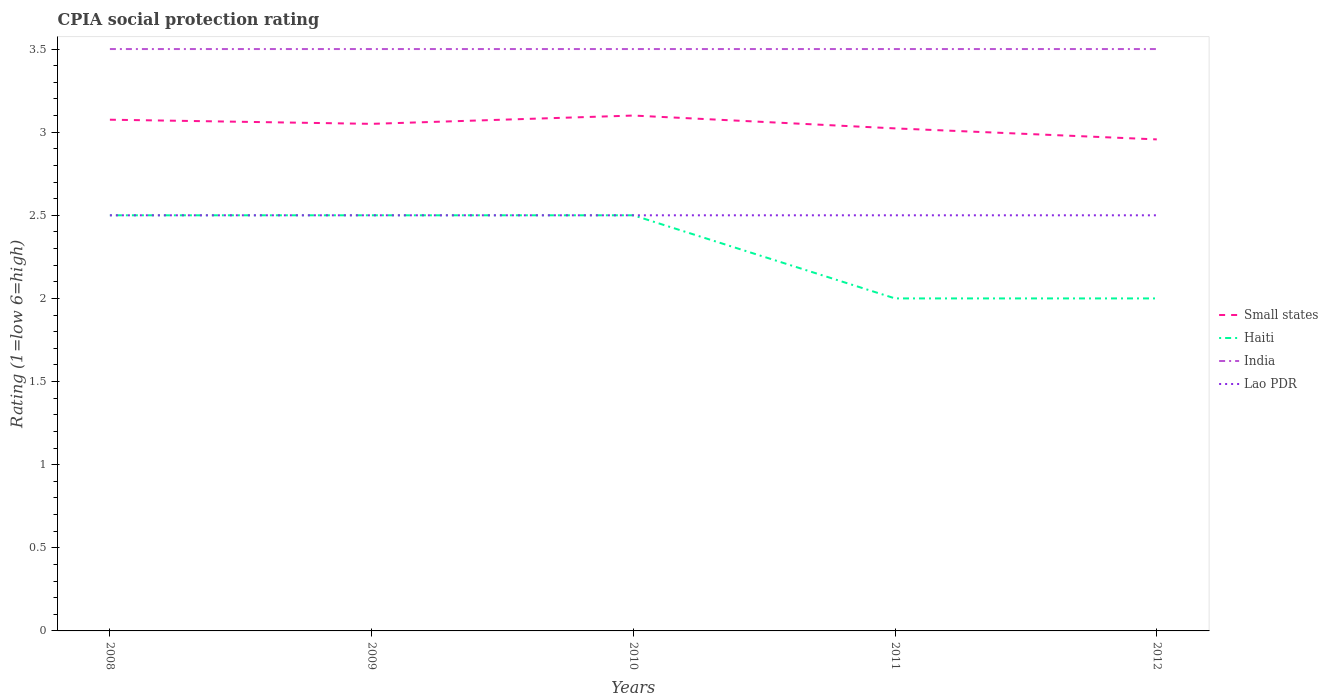Across all years, what is the maximum CPIA rating in Lao PDR?
Make the answer very short. 2.5. In which year was the CPIA rating in Haiti maximum?
Provide a short and direct response. 2011. What is the difference between the highest and the second highest CPIA rating in Haiti?
Provide a succinct answer. 0.5. Is the CPIA rating in Haiti strictly greater than the CPIA rating in India over the years?
Make the answer very short. Yes. How many lines are there?
Make the answer very short. 4. Are the values on the major ticks of Y-axis written in scientific E-notation?
Your response must be concise. No. What is the title of the graph?
Offer a very short reply. CPIA social protection rating. What is the label or title of the X-axis?
Keep it short and to the point. Years. What is the Rating (1=low 6=high) of Small states in 2008?
Offer a very short reply. 3.08. What is the Rating (1=low 6=high) in Haiti in 2008?
Your answer should be very brief. 2.5. What is the Rating (1=low 6=high) in India in 2008?
Ensure brevity in your answer.  3.5. What is the Rating (1=low 6=high) in Small states in 2009?
Give a very brief answer. 3.05. What is the Rating (1=low 6=high) of Haiti in 2010?
Your response must be concise. 2.5. What is the Rating (1=low 6=high) in Lao PDR in 2010?
Offer a very short reply. 2.5. What is the Rating (1=low 6=high) of Small states in 2011?
Keep it short and to the point. 3.02. What is the Rating (1=low 6=high) of Small states in 2012?
Keep it short and to the point. 2.96. Across all years, what is the maximum Rating (1=low 6=high) of Small states?
Make the answer very short. 3.1. Across all years, what is the maximum Rating (1=low 6=high) in Lao PDR?
Your response must be concise. 2.5. Across all years, what is the minimum Rating (1=low 6=high) of Small states?
Provide a short and direct response. 2.96. Across all years, what is the minimum Rating (1=low 6=high) in Haiti?
Your answer should be very brief. 2. What is the total Rating (1=low 6=high) of Small states in the graph?
Ensure brevity in your answer.  15.2. What is the difference between the Rating (1=low 6=high) in Small states in 2008 and that in 2009?
Make the answer very short. 0.03. What is the difference between the Rating (1=low 6=high) of Lao PDR in 2008 and that in 2009?
Make the answer very short. 0. What is the difference between the Rating (1=low 6=high) in Small states in 2008 and that in 2010?
Keep it short and to the point. -0.03. What is the difference between the Rating (1=low 6=high) in India in 2008 and that in 2010?
Keep it short and to the point. 0. What is the difference between the Rating (1=low 6=high) of Small states in 2008 and that in 2011?
Provide a short and direct response. 0.05. What is the difference between the Rating (1=low 6=high) of Haiti in 2008 and that in 2011?
Your answer should be compact. 0.5. What is the difference between the Rating (1=low 6=high) in India in 2008 and that in 2011?
Provide a succinct answer. 0. What is the difference between the Rating (1=low 6=high) in Small states in 2008 and that in 2012?
Ensure brevity in your answer.  0.12. What is the difference between the Rating (1=low 6=high) in Haiti in 2008 and that in 2012?
Your answer should be compact. 0.5. What is the difference between the Rating (1=low 6=high) in Lao PDR in 2009 and that in 2010?
Make the answer very short. 0. What is the difference between the Rating (1=low 6=high) in Small states in 2009 and that in 2011?
Offer a terse response. 0.03. What is the difference between the Rating (1=low 6=high) in India in 2009 and that in 2011?
Provide a short and direct response. 0. What is the difference between the Rating (1=low 6=high) of Lao PDR in 2009 and that in 2011?
Your answer should be compact. 0. What is the difference between the Rating (1=low 6=high) of Small states in 2009 and that in 2012?
Your answer should be very brief. 0.09. What is the difference between the Rating (1=low 6=high) in Lao PDR in 2009 and that in 2012?
Keep it short and to the point. 0. What is the difference between the Rating (1=low 6=high) of Small states in 2010 and that in 2011?
Offer a very short reply. 0.08. What is the difference between the Rating (1=low 6=high) in Haiti in 2010 and that in 2011?
Your answer should be very brief. 0.5. What is the difference between the Rating (1=low 6=high) of Lao PDR in 2010 and that in 2011?
Provide a succinct answer. 0. What is the difference between the Rating (1=low 6=high) of Small states in 2010 and that in 2012?
Your answer should be compact. 0.14. What is the difference between the Rating (1=low 6=high) in Haiti in 2010 and that in 2012?
Provide a short and direct response. 0.5. What is the difference between the Rating (1=low 6=high) of Lao PDR in 2010 and that in 2012?
Provide a short and direct response. 0. What is the difference between the Rating (1=low 6=high) in Small states in 2011 and that in 2012?
Give a very brief answer. 0.07. What is the difference between the Rating (1=low 6=high) in Haiti in 2011 and that in 2012?
Offer a terse response. 0. What is the difference between the Rating (1=low 6=high) of Lao PDR in 2011 and that in 2012?
Offer a very short reply. 0. What is the difference between the Rating (1=low 6=high) in Small states in 2008 and the Rating (1=low 6=high) in Haiti in 2009?
Make the answer very short. 0.57. What is the difference between the Rating (1=low 6=high) in Small states in 2008 and the Rating (1=low 6=high) in India in 2009?
Make the answer very short. -0.42. What is the difference between the Rating (1=low 6=high) in Small states in 2008 and the Rating (1=low 6=high) in Lao PDR in 2009?
Keep it short and to the point. 0.57. What is the difference between the Rating (1=low 6=high) in Haiti in 2008 and the Rating (1=low 6=high) in India in 2009?
Ensure brevity in your answer.  -1. What is the difference between the Rating (1=low 6=high) of Haiti in 2008 and the Rating (1=low 6=high) of Lao PDR in 2009?
Your answer should be compact. 0. What is the difference between the Rating (1=low 6=high) in Small states in 2008 and the Rating (1=low 6=high) in Haiti in 2010?
Make the answer very short. 0.57. What is the difference between the Rating (1=low 6=high) of Small states in 2008 and the Rating (1=low 6=high) of India in 2010?
Offer a terse response. -0.42. What is the difference between the Rating (1=low 6=high) in Small states in 2008 and the Rating (1=low 6=high) in Lao PDR in 2010?
Make the answer very short. 0.57. What is the difference between the Rating (1=low 6=high) in India in 2008 and the Rating (1=low 6=high) in Lao PDR in 2010?
Offer a very short reply. 1. What is the difference between the Rating (1=low 6=high) of Small states in 2008 and the Rating (1=low 6=high) of Haiti in 2011?
Provide a short and direct response. 1.07. What is the difference between the Rating (1=low 6=high) of Small states in 2008 and the Rating (1=low 6=high) of India in 2011?
Your answer should be compact. -0.42. What is the difference between the Rating (1=low 6=high) in Small states in 2008 and the Rating (1=low 6=high) in Lao PDR in 2011?
Offer a terse response. 0.57. What is the difference between the Rating (1=low 6=high) in Haiti in 2008 and the Rating (1=low 6=high) in India in 2011?
Provide a succinct answer. -1. What is the difference between the Rating (1=low 6=high) of Small states in 2008 and the Rating (1=low 6=high) of Haiti in 2012?
Offer a very short reply. 1.07. What is the difference between the Rating (1=low 6=high) of Small states in 2008 and the Rating (1=low 6=high) of India in 2012?
Your answer should be very brief. -0.42. What is the difference between the Rating (1=low 6=high) in Small states in 2008 and the Rating (1=low 6=high) in Lao PDR in 2012?
Offer a terse response. 0.57. What is the difference between the Rating (1=low 6=high) in Haiti in 2008 and the Rating (1=low 6=high) in Lao PDR in 2012?
Give a very brief answer. 0. What is the difference between the Rating (1=low 6=high) in India in 2008 and the Rating (1=low 6=high) in Lao PDR in 2012?
Offer a terse response. 1. What is the difference between the Rating (1=low 6=high) of Small states in 2009 and the Rating (1=low 6=high) of Haiti in 2010?
Your answer should be compact. 0.55. What is the difference between the Rating (1=low 6=high) of Small states in 2009 and the Rating (1=low 6=high) of India in 2010?
Offer a terse response. -0.45. What is the difference between the Rating (1=low 6=high) in Small states in 2009 and the Rating (1=low 6=high) in Lao PDR in 2010?
Offer a very short reply. 0.55. What is the difference between the Rating (1=low 6=high) in Haiti in 2009 and the Rating (1=low 6=high) in Lao PDR in 2010?
Offer a terse response. 0. What is the difference between the Rating (1=low 6=high) of Small states in 2009 and the Rating (1=low 6=high) of Haiti in 2011?
Give a very brief answer. 1.05. What is the difference between the Rating (1=low 6=high) in Small states in 2009 and the Rating (1=low 6=high) in India in 2011?
Give a very brief answer. -0.45. What is the difference between the Rating (1=low 6=high) of Small states in 2009 and the Rating (1=low 6=high) of Lao PDR in 2011?
Give a very brief answer. 0.55. What is the difference between the Rating (1=low 6=high) in Haiti in 2009 and the Rating (1=low 6=high) in Lao PDR in 2011?
Provide a succinct answer. 0. What is the difference between the Rating (1=low 6=high) in Small states in 2009 and the Rating (1=low 6=high) in India in 2012?
Ensure brevity in your answer.  -0.45. What is the difference between the Rating (1=low 6=high) of Small states in 2009 and the Rating (1=low 6=high) of Lao PDR in 2012?
Provide a short and direct response. 0.55. What is the difference between the Rating (1=low 6=high) in Small states in 2010 and the Rating (1=low 6=high) in Lao PDR in 2011?
Provide a short and direct response. 0.6. What is the difference between the Rating (1=low 6=high) of Small states in 2010 and the Rating (1=low 6=high) of Haiti in 2012?
Give a very brief answer. 1.1. What is the difference between the Rating (1=low 6=high) in Small states in 2010 and the Rating (1=low 6=high) in Lao PDR in 2012?
Give a very brief answer. 0.6. What is the difference between the Rating (1=low 6=high) in Haiti in 2010 and the Rating (1=low 6=high) in Lao PDR in 2012?
Offer a very short reply. 0. What is the difference between the Rating (1=low 6=high) in India in 2010 and the Rating (1=low 6=high) in Lao PDR in 2012?
Offer a very short reply. 1. What is the difference between the Rating (1=low 6=high) of Small states in 2011 and the Rating (1=low 6=high) of Haiti in 2012?
Give a very brief answer. 1.02. What is the difference between the Rating (1=low 6=high) in Small states in 2011 and the Rating (1=low 6=high) in India in 2012?
Offer a very short reply. -0.48. What is the difference between the Rating (1=low 6=high) in Small states in 2011 and the Rating (1=low 6=high) in Lao PDR in 2012?
Provide a short and direct response. 0.52. What is the difference between the Rating (1=low 6=high) in Haiti in 2011 and the Rating (1=low 6=high) in Lao PDR in 2012?
Provide a succinct answer. -0.5. What is the difference between the Rating (1=low 6=high) in India in 2011 and the Rating (1=low 6=high) in Lao PDR in 2012?
Make the answer very short. 1. What is the average Rating (1=low 6=high) in Small states per year?
Your answer should be very brief. 3.04. What is the average Rating (1=low 6=high) of Lao PDR per year?
Offer a very short reply. 2.5. In the year 2008, what is the difference between the Rating (1=low 6=high) of Small states and Rating (1=low 6=high) of Haiti?
Give a very brief answer. 0.57. In the year 2008, what is the difference between the Rating (1=low 6=high) of Small states and Rating (1=low 6=high) of India?
Ensure brevity in your answer.  -0.42. In the year 2008, what is the difference between the Rating (1=low 6=high) of Small states and Rating (1=low 6=high) of Lao PDR?
Provide a succinct answer. 0.57. In the year 2008, what is the difference between the Rating (1=low 6=high) of Haiti and Rating (1=low 6=high) of India?
Offer a terse response. -1. In the year 2008, what is the difference between the Rating (1=low 6=high) in Haiti and Rating (1=low 6=high) in Lao PDR?
Offer a very short reply. 0. In the year 2008, what is the difference between the Rating (1=low 6=high) in India and Rating (1=low 6=high) in Lao PDR?
Offer a terse response. 1. In the year 2009, what is the difference between the Rating (1=low 6=high) of Small states and Rating (1=low 6=high) of Haiti?
Your answer should be compact. 0.55. In the year 2009, what is the difference between the Rating (1=low 6=high) in Small states and Rating (1=low 6=high) in India?
Keep it short and to the point. -0.45. In the year 2009, what is the difference between the Rating (1=low 6=high) of Small states and Rating (1=low 6=high) of Lao PDR?
Ensure brevity in your answer.  0.55. In the year 2009, what is the difference between the Rating (1=low 6=high) of Haiti and Rating (1=low 6=high) of India?
Offer a terse response. -1. In the year 2009, what is the difference between the Rating (1=low 6=high) in Haiti and Rating (1=low 6=high) in Lao PDR?
Your answer should be compact. 0. In the year 2009, what is the difference between the Rating (1=low 6=high) of India and Rating (1=low 6=high) of Lao PDR?
Ensure brevity in your answer.  1. In the year 2010, what is the difference between the Rating (1=low 6=high) of Small states and Rating (1=low 6=high) of India?
Provide a short and direct response. -0.4. In the year 2010, what is the difference between the Rating (1=low 6=high) in Small states and Rating (1=low 6=high) in Lao PDR?
Make the answer very short. 0.6. In the year 2011, what is the difference between the Rating (1=low 6=high) in Small states and Rating (1=low 6=high) in Haiti?
Offer a very short reply. 1.02. In the year 2011, what is the difference between the Rating (1=low 6=high) of Small states and Rating (1=low 6=high) of India?
Provide a succinct answer. -0.48. In the year 2011, what is the difference between the Rating (1=low 6=high) in Small states and Rating (1=low 6=high) in Lao PDR?
Keep it short and to the point. 0.52. In the year 2012, what is the difference between the Rating (1=low 6=high) of Small states and Rating (1=low 6=high) of Haiti?
Provide a short and direct response. 0.96. In the year 2012, what is the difference between the Rating (1=low 6=high) in Small states and Rating (1=low 6=high) in India?
Ensure brevity in your answer.  -0.54. In the year 2012, what is the difference between the Rating (1=low 6=high) of Small states and Rating (1=low 6=high) of Lao PDR?
Ensure brevity in your answer.  0.46. In the year 2012, what is the difference between the Rating (1=low 6=high) in Haiti and Rating (1=low 6=high) in Lao PDR?
Your answer should be very brief. -0.5. In the year 2012, what is the difference between the Rating (1=low 6=high) of India and Rating (1=low 6=high) of Lao PDR?
Keep it short and to the point. 1. What is the ratio of the Rating (1=low 6=high) of Small states in 2008 to that in 2009?
Your answer should be very brief. 1.01. What is the ratio of the Rating (1=low 6=high) of Haiti in 2008 to that in 2009?
Provide a succinct answer. 1. What is the ratio of the Rating (1=low 6=high) in Haiti in 2008 to that in 2010?
Offer a very short reply. 1. What is the ratio of the Rating (1=low 6=high) in Lao PDR in 2008 to that in 2010?
Your answer should be very brief. 1. What is the ratio of the Rating (1=low 6=high) of Small states in 2008 to that in 2011?
Provide a short and direct response. 1.02. What is the ratio of the Rating (1=low 6=high) of Small states in 2008 to that in 2012?
Your answer should be very brief. 1.04. What is the ratio of the Rating (1=low 6=high) in Haiti in 2008 to that in 2012?
Make the answer very short. 1.25. What is the ratio of the Rating (1=low 6=high) in India in 2008 to that in 2012?
Your response must be concise. 1. What is the ratio of the Rating (1=low 6=high) of Lao PDR in 2008 to that in 2012?
Your answer should be compact. 1. What is the ratio of the Rating (1=low 6=high) of Small states in 2009 to that in 2010?
Make the answer very short. 0.98. What is the ratio of the Rating (1=low 6=high) of India in 2009 to that in 2010?
Offer a terse response. 1. What is the ratio of the Rating (1=low 6=high) of Small states in 2009 to that in 2011?
Give a very brief answer. 1.01. What is the ratio of the Rating (1=low 6=high) of India in 2009 to that in 2011?
Provide a succinct answer. 1. What is the ratio of the Rating (1=low 6=high) of Small states in 2009 to that in 2012?
Offer a very short reply. 1.03. What is the ratio of the Rating (1=low 6=high) in India in 2009 to that in 2012?
Offer a very short reply. 1. What is the ratio of the Rating (1=low 6=high) of Small states in 2010 to that in 2011?
Provide a short and direct response. 1.03. What is the ratio of the Rating (1=low 6=high) of India in 2010 to that in 2011?
Your answer should be very brief. 1. What is the ratio of the Rating (1=low 6=high) of Lao PDR in 2010 to that in 2011?
Offer a terse response. 1. What is the ratio of the Rating (1=low 6=high) in Small states in 2010 to that in 2012?
Offer a terse response. 1.05. What is the ratio of the Rating (1=low 6=high) in Haiti in 2010 to that in 2012?
Your answer should be compact. 1.25. What is the ratio of the Rating (1=low 6=high) in India in 2010 to that in 2012?
Offer a terse response. 1. What is the ratio of the Rating (1=low 6=high) of Small states in 2011 to that in 2012?
Keep it short and to the point. 1.02. What is the ratio of the Rating (1=low 6=high) in Haiti in 2011 to that in 2012?
Your answer should be very brief. 1. What is the ratio of the Rating (1=low 6=high) of India in 2011 to that in 2012?
Your answer should be compact. 1. What is the ratio of the Rating (1=low 6=high) of Lao PDR in 2011 to that in 2012?
Provide a short and direct response. 1. What is the difference between the highest and the second highest Rating (1=low 6=high) in Small states?
Provide a succinct answer. 0.03. What is the difference between the highest and the second highest Rating (1=low 6=high) in India?
Your response must be concise. 0. What is the difference between the highest and the lowest Rating (1=low 6=high) of Small states?
Your response must be concise. 0.14. What is the difference between the highest and the lowest Rating (1=low 6=high) of India?
Make the answer very short. 0. 